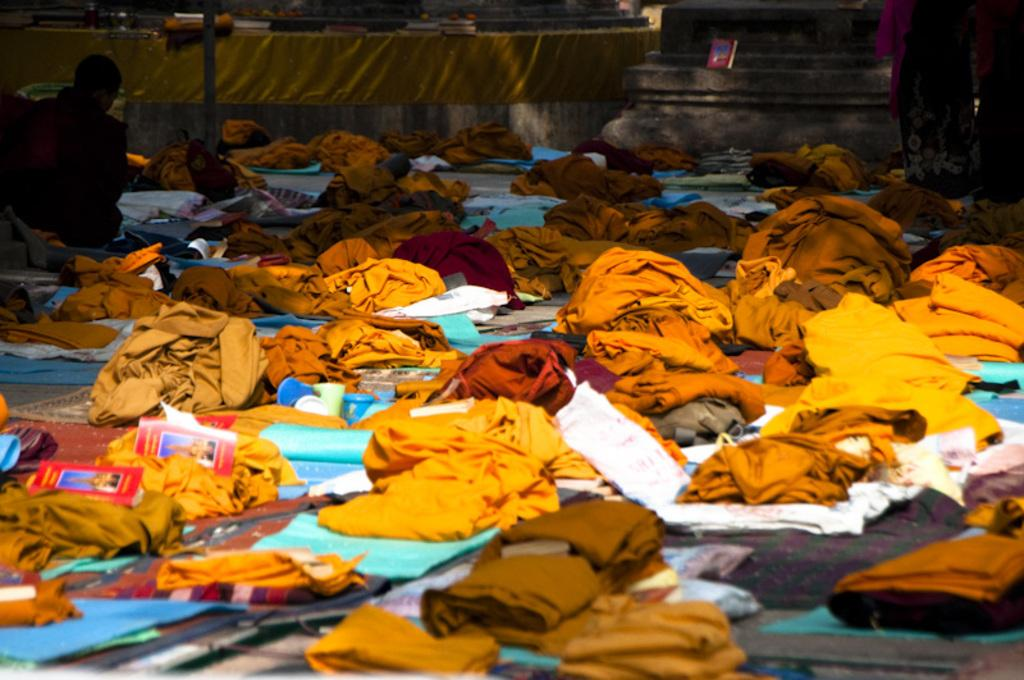Who or what is present in the image? There are people in the image. What else can be seen in the image besides the people? There are many clothes and books in the image. What is visible in the background of the image? There is a wall in the background of the image. What type of sweater is being used as a spade in the image? There is no sweater or spade present in the image. How many rifles can be seen in the image? There are no rifles present in the image. 